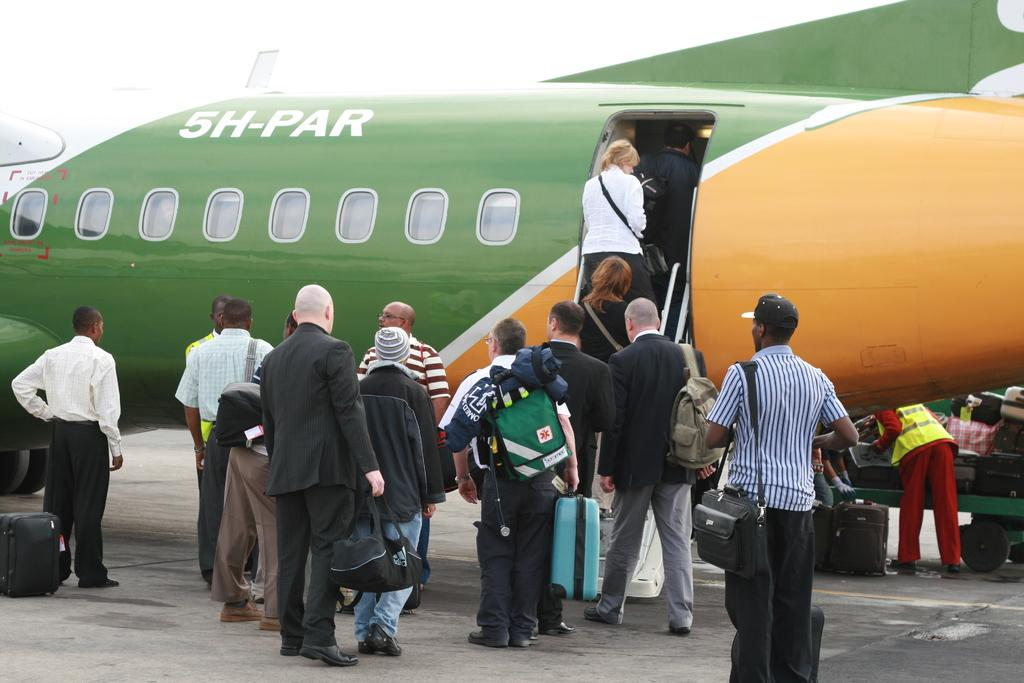Provide a one-sentence caption for the provided image. People are boarding on a commercial airplane with the name SH-PAR on it. 